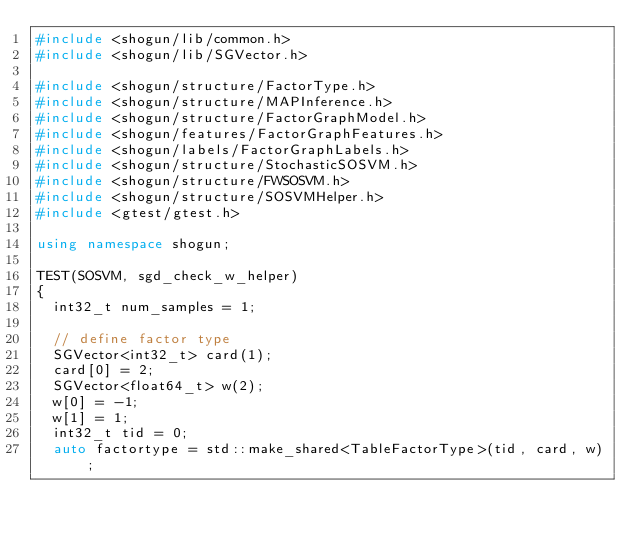Convert code to text. <code><loc_0><loc_0><loc_500><loc_500><_C++_>#include <shogun/lib/common.h>
#include <shogun/lib/SGVector.h>

#include <shogun/structure/FactorType.h>
#include <shogun/structure/MAPInference.h>
#include <shogun/structure/FactorGraphModel.h>
#include <shogun/features/FactorGraphFeatures.h>
#include <shogun/labels/FactorGraphLabels.h>
#include <shogun/structure/StochasticSOSVM.h>
#include <shogun/structure/FWSOSVM.h>
#include <shogun/structure/SOSVMHelper.h>
#include <gtest/gtest.h>

using namespace shogun;

TEST(SOSVM, sgd_check_w_helper)
{
	int32_t num_samples = 1;

	// define factor type
	SGVector<int32_t> card(1);
	card[0] = 2;
	SGVector<float64_t> w(2);
	w[0] = -1;
	w[1] = 1;
	int32_t tid = 0;
	auto factortype = std::make_shared<TableFactorType>(tid, card, w);

</code> 